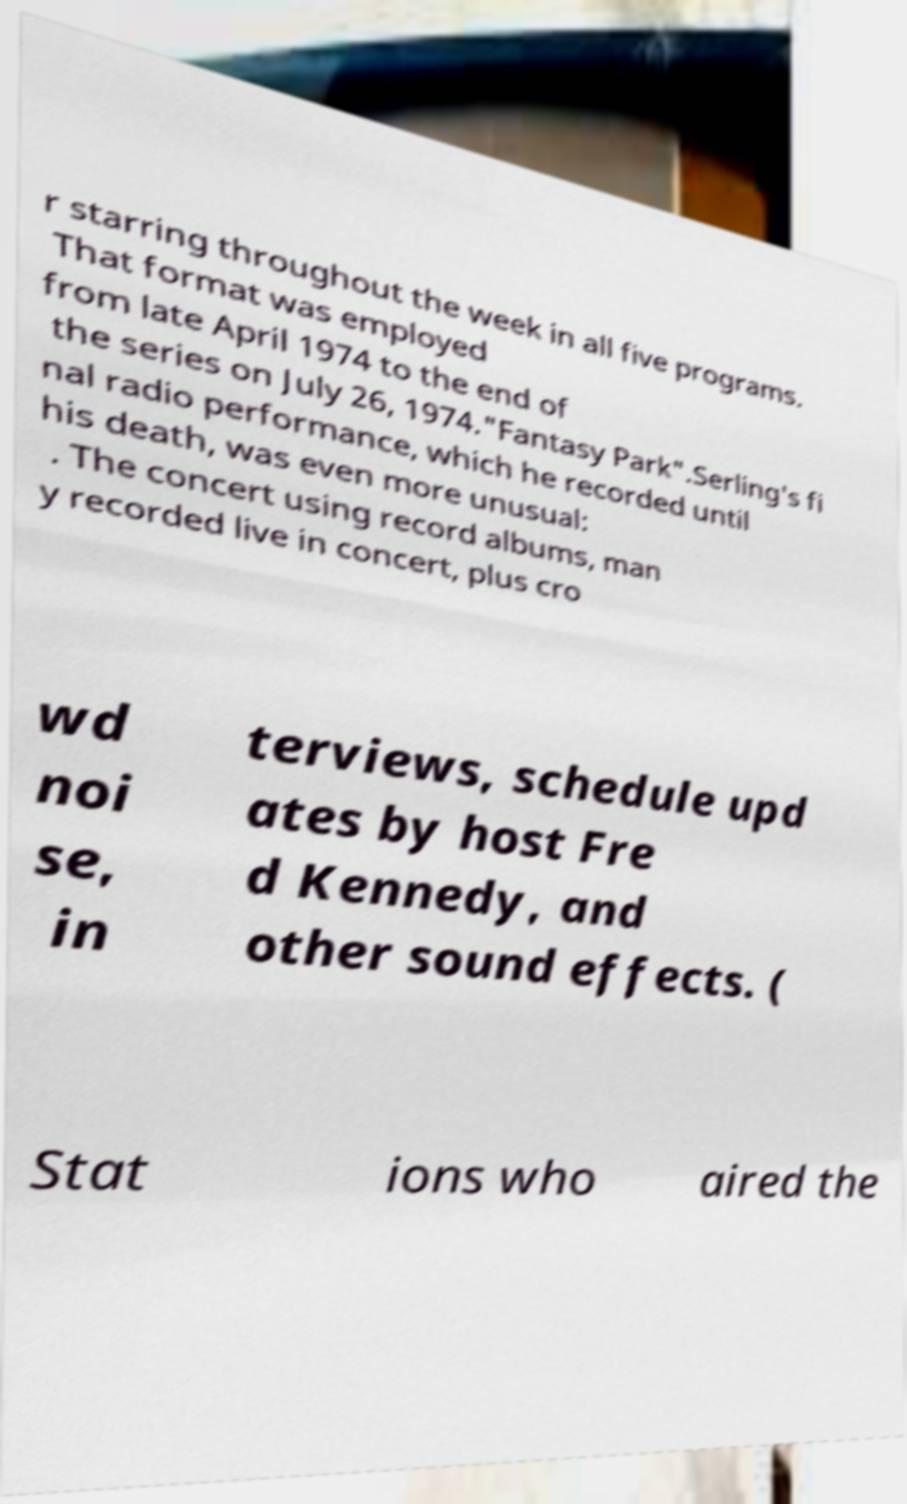Please identify and transcribe the text found in this image. r starring throughout the week in all five programs. That format was employed from late April 1974 to the end of the series on July 26, 1974."Fantasy Park".Serling's fi nal radio performance, which he recorded until his death, was even more unusual: . The concert using record albums, man y recorded live in concert, plus cro wd noi se, in terviews, schedule upd ates by host Fre d Kennedy, and other sound effects. ( Stat ions who aired the 